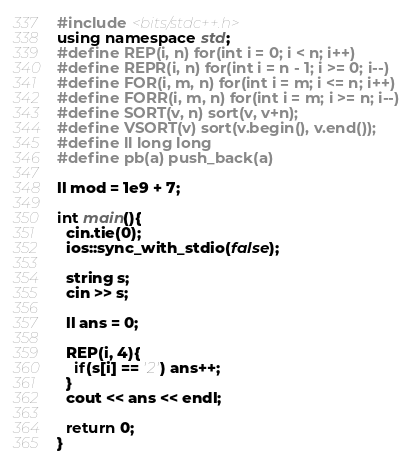Convert code to text. <code><loc_0><loc_0><loc_500><loc_500><_C++_>#include <bits/stdc++.h>
using namespace std;
#define REP(i, n) for(int i = 0; i < n; i++)
#define REPR(i, n) for(int i = n - 1; i >= 0; i--)
#define FOR(i, m, n) for(int i = m; i <= n; i++)
#define FORR(i, m, n) for(int i = m; i >= n; i--)
#define SORT(v, n) sort(v, v+n);
#define VSORT(v) sort(v.begin(), v.end());
#define ll long long
#define pb(a) push_back(a)

ll mod = 1e9 + 7;

int main(){
  cin.tie(0);
  ios::sync_with_stdio(false);

  string s;
  cin >> s;

  ll ans = 0;

  REP(i, 4){
    if(s[i] == '2') ans++;
  }
  cout << ans << endl;

  return 0;
}
</code> 